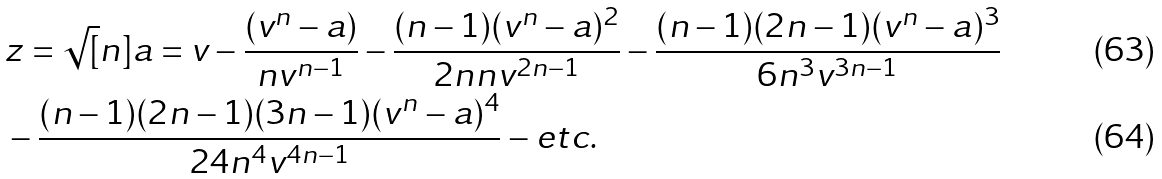Convert formula to latex. <formula><loc_0><loc_0><loc_500><loc_500>& z = \sqrt { [ } n ] { a } = v - \frac { ( v ^ { n } - a ) } { n v ^ { n - 1 } } - \frac { ( n - 1 ) ( v ^ { n } - a ) ^ { 2 } } { 2 n n v ^ { 2 n - 1 } } - \frac { ( n - 1 ) ( 2 n - 1 ) ( v ^ { n } - a ) ^ { 3 } } { 6 n ^ { 3 } v ^ { 3 n - 1 } } \\ & - \frac { ( n - 1 ) ( 2 n - 1 ) ( 3 n - 1 ) ( v ^ { n } - a ) ^ { 4 } } { 2 4 n ^ { 4 } v ^ { 4 n - 1 } } - e t c .</formula> 